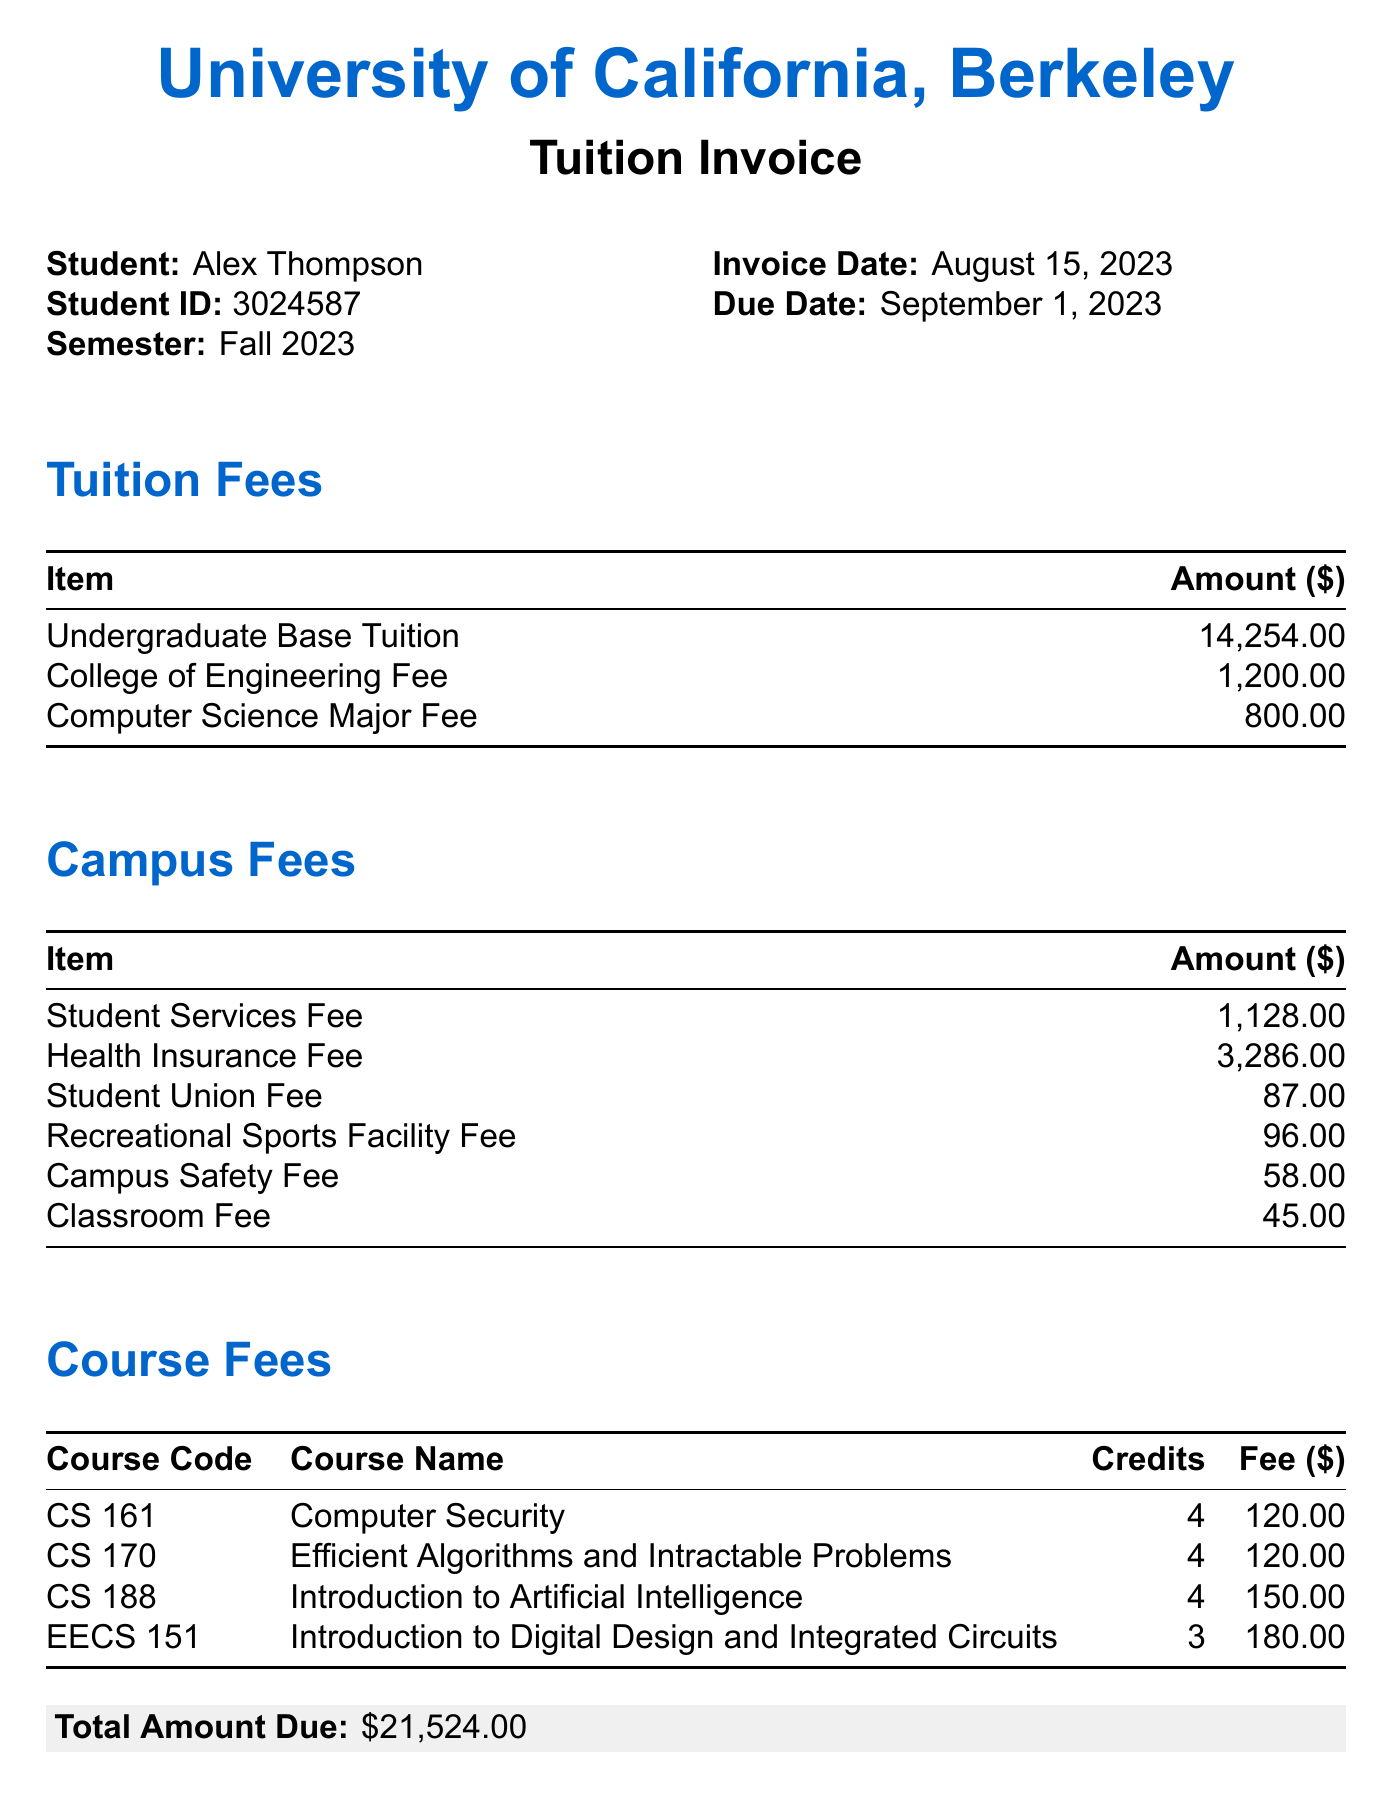What is the university name? The university name is prominently displayed at the top of the invoice.
Answer: University of California, Berkeley What is the student ID? The student ID is listed in the section detailing the student's information.
Answer: 3024587 When is the invoice date? The invoice date can be found under the student's information section.
Answer: August 15, 2023 What is the amount for the Health Insurance Fee? This fee is specified in the Campus Fees section of the document.
Answer: 3286 How many credits is the course CS 188 worth? The credits for each course are listed next to the course names in the Course Fees section.
Answer: 4 What is the total amount due? The total amount due is highlighted in the document and calculated from all fees.
Answer: 21524 What fee applies after the due date? The additional notes at the bottom of the invoice mention a specific late fee.
Answer: 100 Which course has the highest fee? By comparing the fees in the Course Fees section, we identify the course with the highest fee.
Answer: CS 188 Who should be contacted for billing questions? The additional notes mention the contact for billing inquiries specifically.
Answer: Billing and Payment Services 